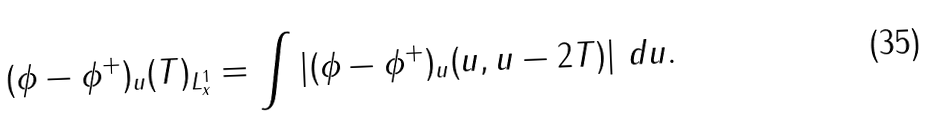<formula> <loc_0><loc_0><loc_500><loc_500>\| ( \phi - \phi ^ { + } ) _ { u } ( T ) \| _ { L ^ { 1 } _ { x } } = \int | ( \phi - \phi ^ { + } ) _ { u } ( u , u - 2 T ) | \ d u .</formula> 